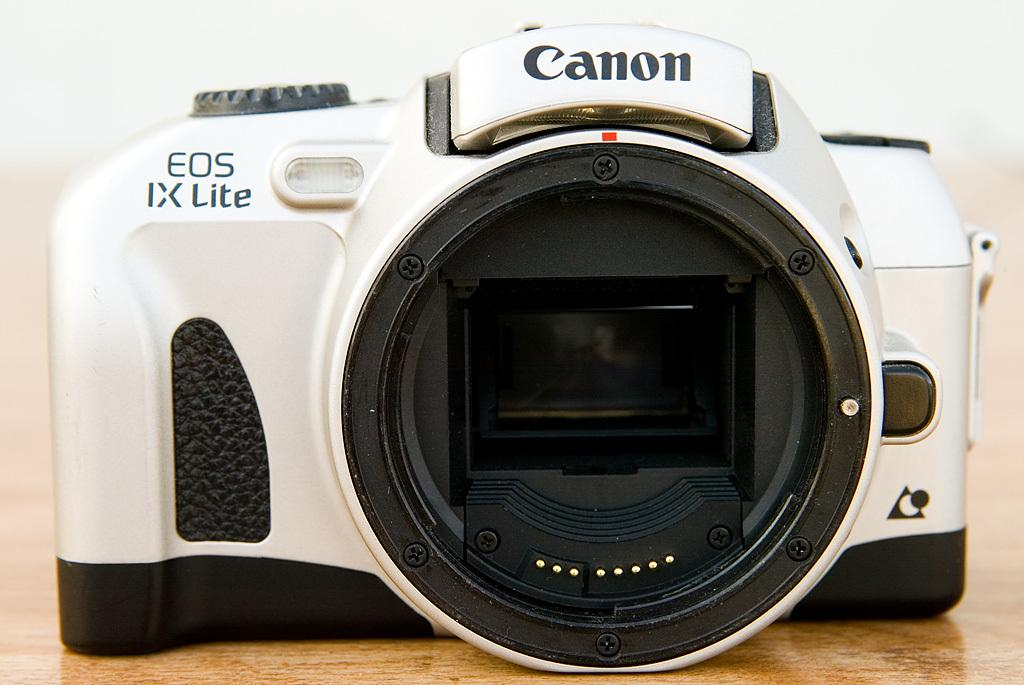<image>
Summarize the visual content of the image. The black and white CANON camera has EOS IX Lite on it. 